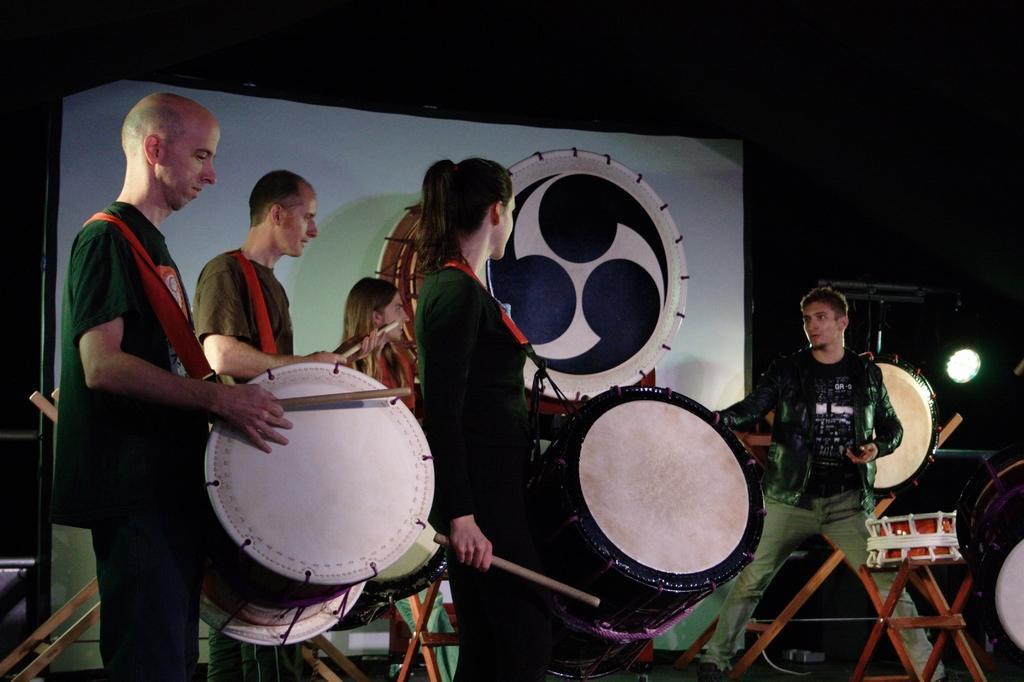Please provide a concise description of this image. Here we can see a group of people are standing and playing the drums, and in front here the person is standing, and at back here are the lights, and here are the drums. 